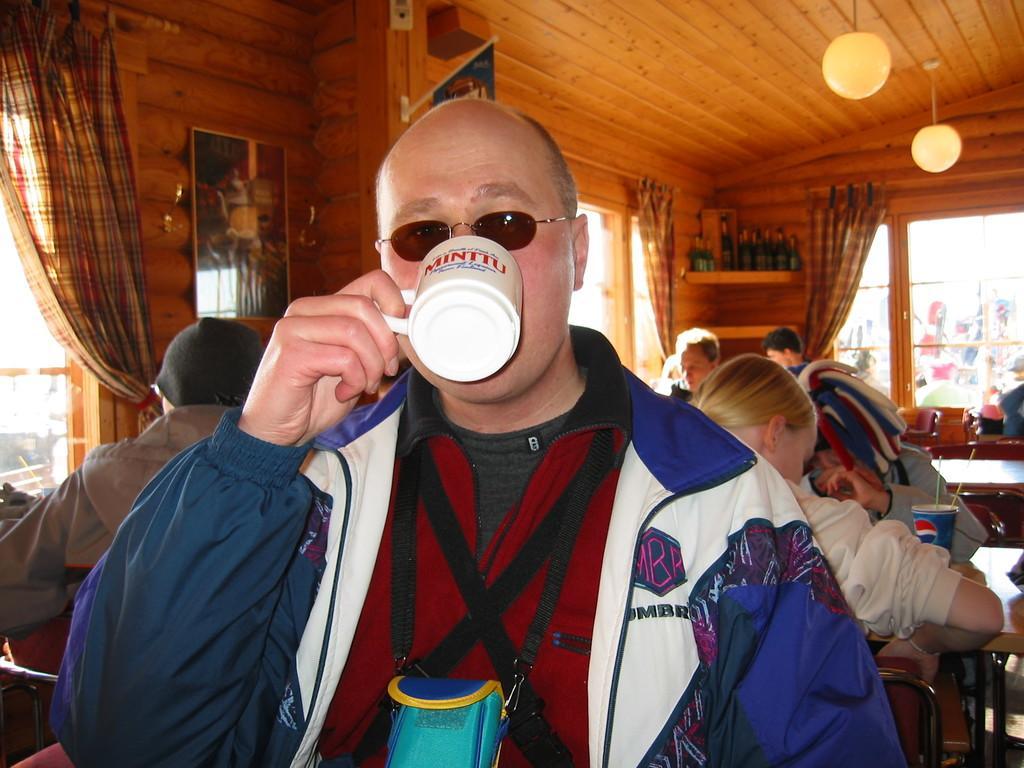Could you give a brief overview of what you see in this image? This picture shows few people seated on the chairs and we see a man seated and he wore sunglasses on his face and holding a cup in his hand and drinking and we see a man seated and he wore a cap on his head and we see curtains to the windows and few bottles on the shelf and we see tables and a cup on it and we see a mirror on the wall. 